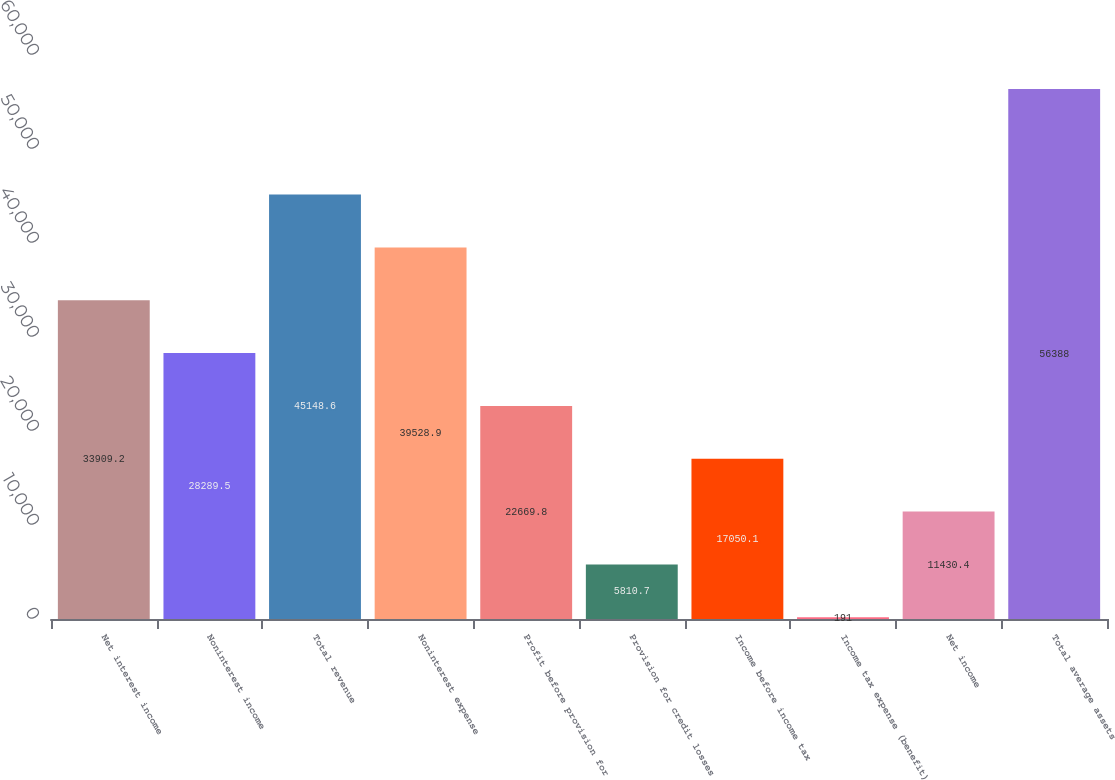<chart> <loc_0><loc_0><loc_500><loc_500><bar_chart><fcel>Net interest income<fcel>Noninterest income<fcel>Total revenue<fcel>Noninterest expense<fcel>Profit before provision for<fcel>Provision for credit losses<fcel>Income before income tax<fcel>Income tax expense (benefit)<fcel>Net income<fcel>Total average assets<nl><fcel>33909.2<fcel>28289.5<fcel>45148.6<fcel>39528.9<fcel>22669.8<fcel>5810.7<fcel>17050.1<fcel>191<fcel>11430.4<fcel>56388<nl></chart> 